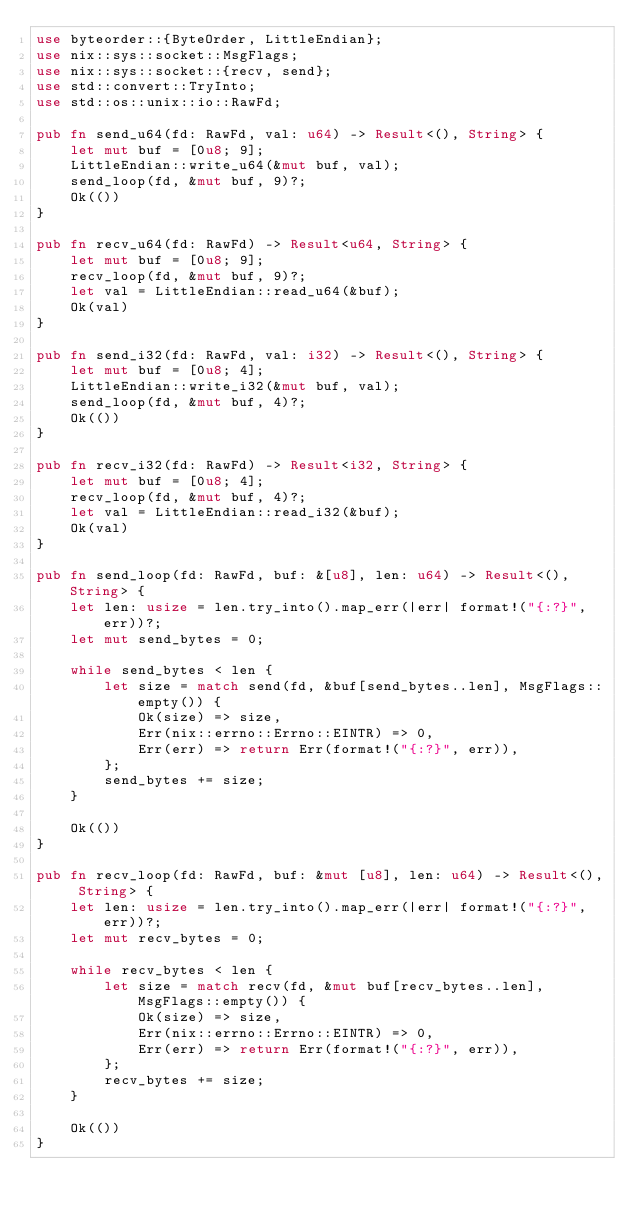<code> <loc_0><loc_0><loc_500><loc_500><_Rust_>use byteorder::{ByteOrder, LittleEndian};
use nix::sys::socket::MsgFlags;
use nix::sys::socket::{recv, send};
use std::convert::TryInto;
use std::os::unix::io::RawFd;

pub fn send_u64(fd: RawFd, val: u64) -> Result<(), String> {
    let mut buf = [0u8; 9];
    LittleEndian::write_u64(&mut buf, val);
    send_loop(fd, &mut buf, 9)?;
    Ok(())
}

pub fn recv_u64(fd: RawFd) -> Result<u64, String> {
    let mut buf = [0u8; 9];
    recv_loop(fd, &mut buf, 9)?;
    let val = LittleEndian::read_u64(&buf);
    Ok(val)
}

pub fn send_i32(fd: RawFd, val: i32) -> Result<(), String> {
    let mut buf = [0u8; 4];
    LittleEndian::write_i32(&mut buf, val);
    send_loop(fd, &mut buf, 4)?;
    Ok(())
}

pub fn recv_i32(fd: RawFd) -> Result<i32, String> {
    let mut buf = [0u8; 4];
    recv_loop(fd, &mut buf, 4)?;
    let val = LittleEndian::read_i32(&buf);
    Ok(val)
}

pub fn send_loop(fd: RawFd, buf: &[u8], len: u64) -> Result<(), String> {
    let len: usize = len.try_into().map_err(|err| format!("{:?}", err))?;
    let mut send_bytes = 0;

    while send_bytes < len {
        let size = match send(fd, &buf[send_bytes..len], MsgFlags::empty()) {
            Ok(size) => size,
            Err(nix::errno::Errno::EINTR) => 0,
            Err(err) => return Err(format!("{:?}", err)),
        };
        send_bytes += size;
    }

    Ok(())
}

pub fn recv_loop(fd: RawFd, buf: &mut [u8], len: u64) -> Result<(), String> {
    let len: usize = len.try_into().map_err(|err| format!("{:?}", err))?;
    let mut recv_bytes = 0;

    while recv_bytes < len {
        let size = match recv(fd, &mut buf[recv_bytes..len], MsgFlags::empty()) {
            Ok(size) => size,
            Err(nix::errno::Errno::EINTR) => 0,
            Err(err) => return Err(format!("{:?}", err)),
        };
        recv_bytes += size;
    }

    Ok(())
}
</code> 